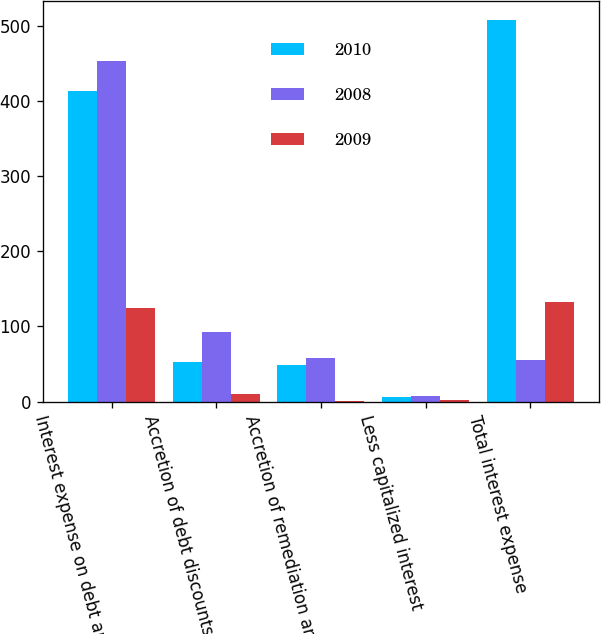<chart> <loc_0><loc_0><loc_500><loc_500><stacked_bar_chart><ecel><fcel>Interest expense on debt and<fcel>Accretion of debt discounts<fcel>Accretion of remediation and<fcel>Less capitalized interest<fcel>Total interest expense<nl><fcel>2010<fcel>413.2<fcel>52.4<fcel>48.1<fcel>6.3<fcel>507.4<nl><fcel>2008<fcel>453.5<fcel>92.1<fcel>58.1<fcel>7.8<fcel>55.25<nl><fcel>2009<fcel>123.9<fcel>10.1<fcel>0.5<fcel>2.6<fcel>131.9<nl></chart> 